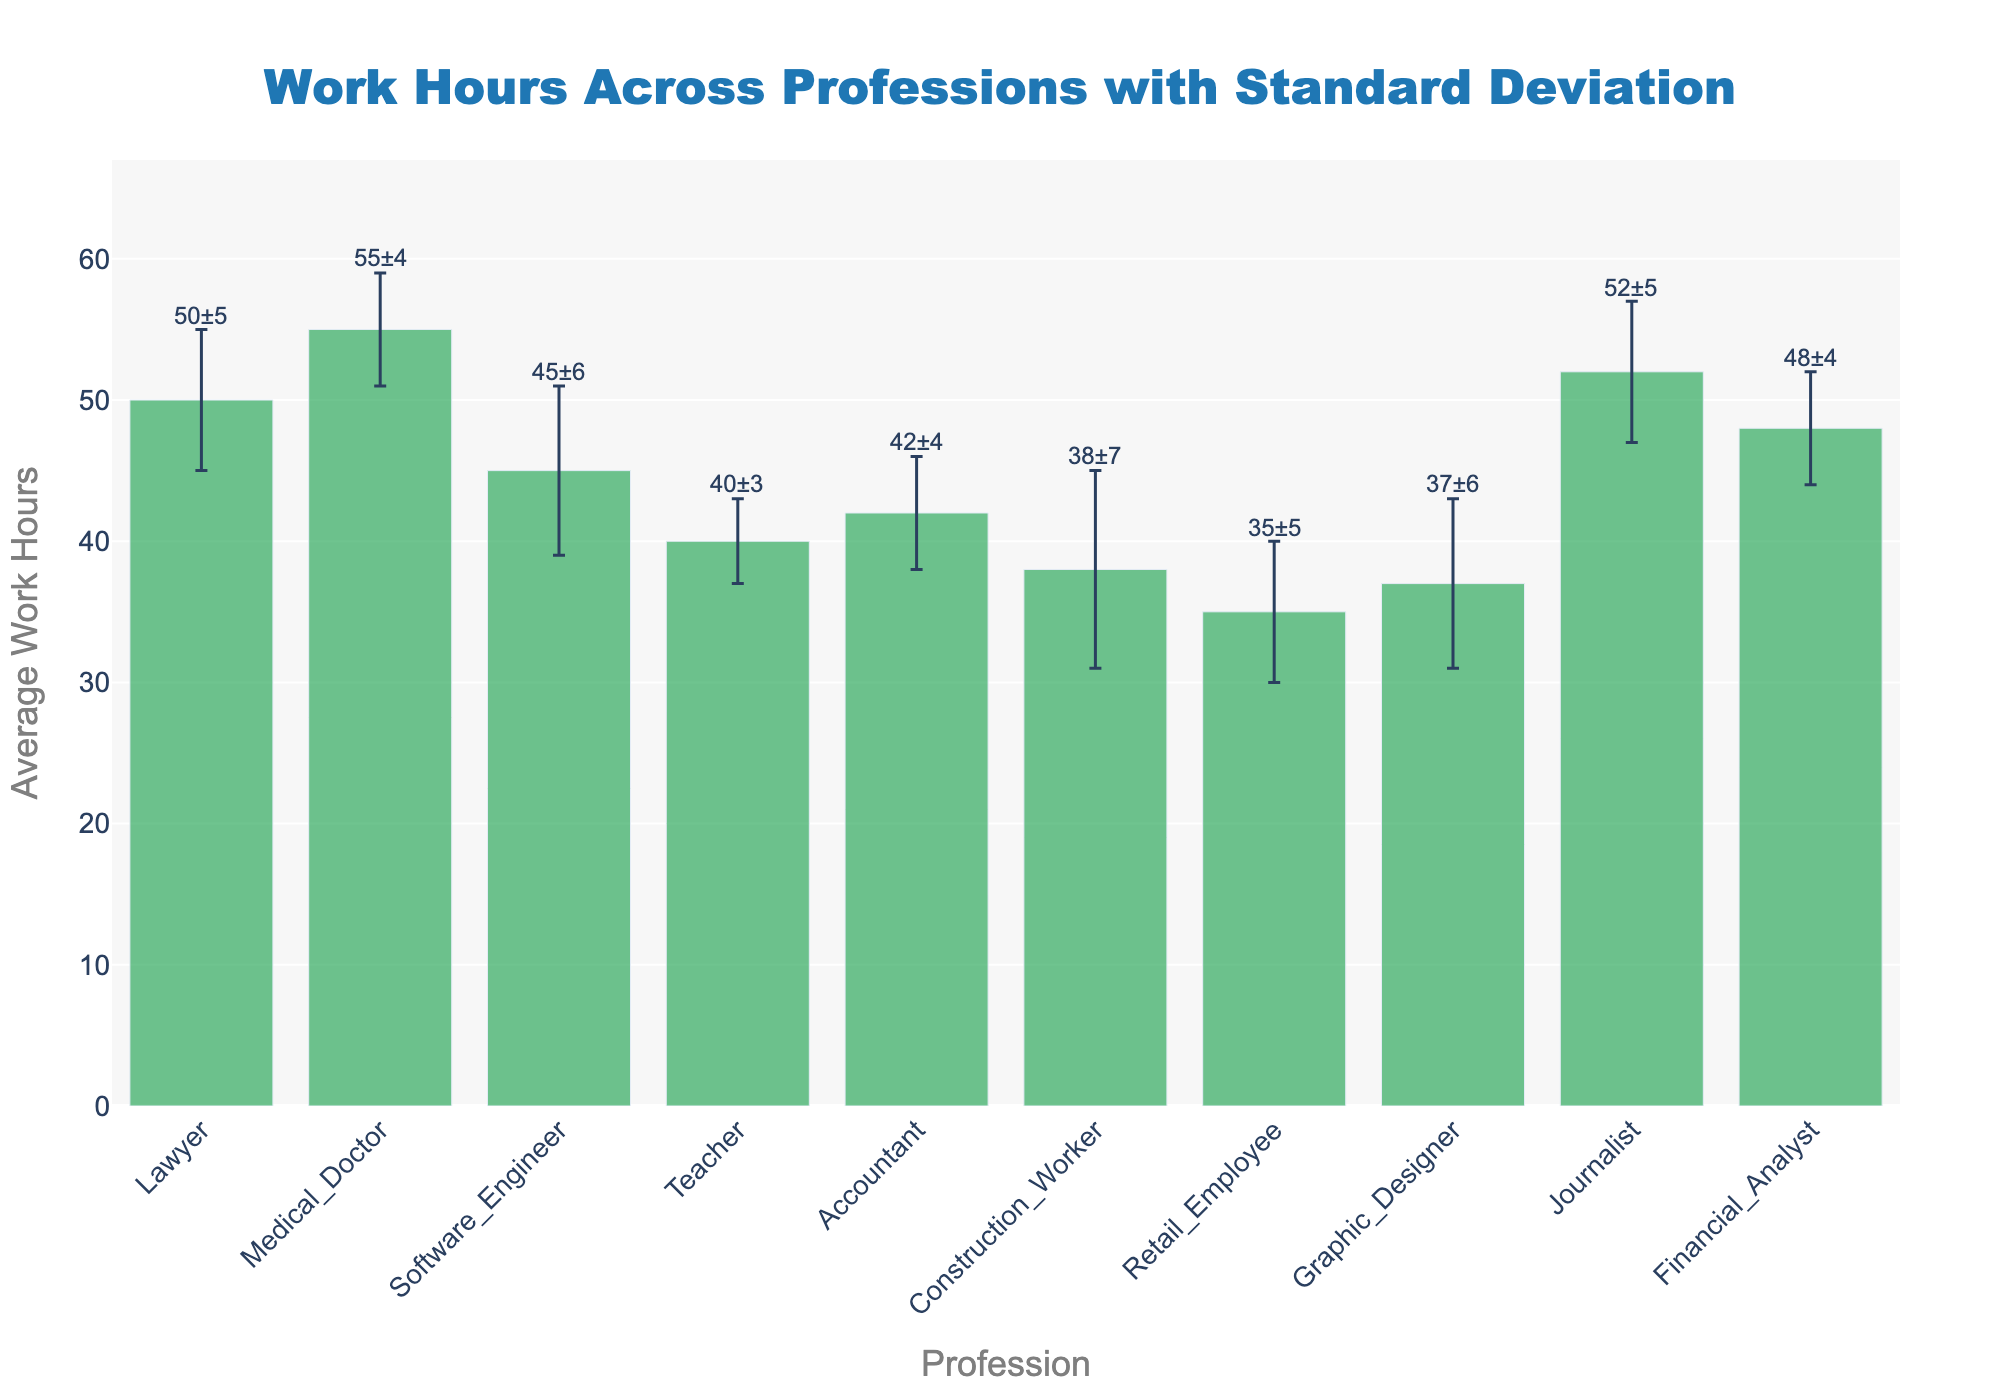What is the title of the figure? The title is displayed at the top of the figure and is usually used to describe what the data represents. In this case, the title is clearly mentioned at the top center of the figure.
Answer: Work Hours Across Professions with Standard Deviation Which profession has the highest average work hours? Look at the lengths of the bars and find the bar that extends the farthest along the y-axis. The one with the greatest height represents the highest average work hours.
Answer: Medical Doctor What is the average work hours for teachers? Check the bar labelled "Teacher" on the x-axis and see where it reaches on the y-axis. The annotation above it also specifies the value.
Answer: 40 hours What is the standard deviation for software engineers? The standard deviation is indicated by the error bars extending above and below the bar. The annotation above the bar also specifies this value.
Answer: 6 hours Which profession has the largest standard deviation in work hours? Compare the lengths of the error bars (the vertical lines extending above and below each bar). The longest one represents the largest standard deviation.
Answer: Construction Worker How do the average work hours of a lawyer compare to those of an accountant? Look at the heights of the bars for "Lawyer" and "Accountant". The bar for the lawyer is higher, indicating that they work more hours on average.
Answer: Lawyers have higher average work hours than accountants What is the difference in average work hours between the profession with the highest and lowest average? Identify the bars with the maximum and minimum heights, which are for "Medical Doctor" and "Retail Employee" respectively. Subtract the average work hours of the lowest from the highest.
Answer: 20 hours Which professions have average work hours within the range of 40 to 45 hours? Check the bars whose heights fall within the range 40 to 45 on the y-axis.
Answer: Teacher, Accountant What is the approximate range of average work hours across all professions displayed in the figure? Find the minimum and maximum values of the bars along the y-axis and compute their range. The smallest value (35) for "Retail Employee" and the largest value (55) for "Medical Doctor".
Answer: 20 hours Does the profession with the highest average work hours also have the highest standard deviation? Compare the bars and error bars of "Medical Doctor" (highest average work hours) with the other professions. The highest standard deviation belongs to the "Construction Worker".
Answer: No 